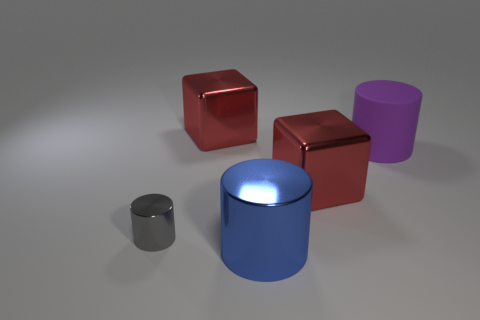Subtract all metal cylinders. How many cylinders are left? 1 Add 4 cylinders. How many objects exist? 9 Subtract all cylinders. How many objects are left? 2 Subtract 1 cylinders. How many cylinders are left? 2 Subtract all purple cylinders. How many cylinders are left? 2 Add 3 big red metallic cubes. How many big red metallic cubes exist? 5 Subtract 0 yellow cylinders. How many objects are left? 5 Subtract all gray cubes. Subtract all blue balls. How many cubes are left? 2 Subtract all small green shiny cylinders. Subtract all gray objects. How many objects are left? 4 Add 3 blue metallic cylinders. How many blue metallic cylinders are left? 4 